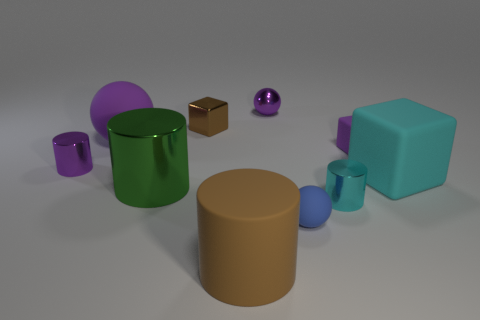How many things are either large yellow shiny spheres or big green metallic things?
Offer a terse response. 1. There is a small sphere in front of the brown metallic object; what is its color?
Your response must be concise. Blue. What is the size of the brown object that is the same shape as the large green metal object?
Provide a short and direct response. Large. What number of things are either small balls that are in front of the large cyan rubber block or big matte objects in front of the tiny cyan shiny object?
Ensure brevity in your answer.  2. There is a metal object that is in front of the small purple metallic cylinder and behind the tiny cyan metal cylinder; how big is it?
Make the answer very short. Large. Does the blue rubber object have the same shape as the purple rubber object that is on the left side of the brown metallic object?
Your answer should be compact. Yes. How many objects are small metallic cylinders in front of the big cyan cube or rubber objects?
Keep it short and to the point. 6. Is the tiny purple cube made of the same material as the sphere that is in front of the big matte ball?
Ensure brevity in your answer.  Yes. There is a purple object that is right of the small metal thing that is in front of the large block; what is its shape?
Offer a very short reply. Cube. Is the color of the big rubber cube the same as the tiny cylinder right of the brown cylinder?
Give a very brief answer. Yes. 